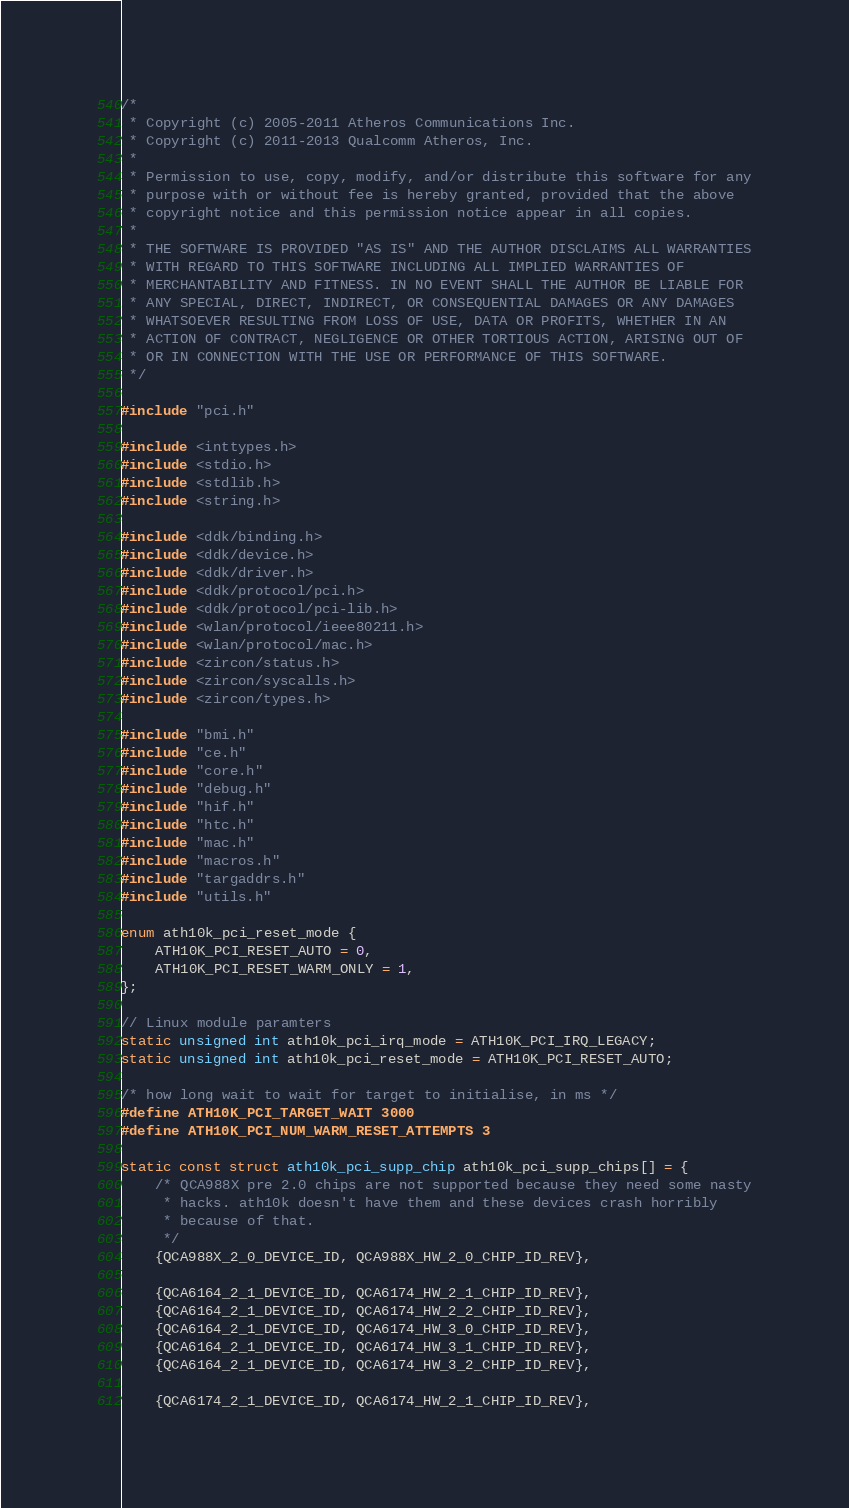Convert code to text. <code><loc_0><loc_0><loc_500><loc_500><_C_>/*
 * Copyright (c) 2005-2011 Atheros Communications Inc.
 * Copyright (c) 2011-2013 Qualcomm Atheros, Inc.
 *
 * Permission to use, copy, modify, and/or distribute this software for any
 * purpose with or without fee is hereby granted, provided that the above
 * copyright notice and this permission notice appear in all copies.
 *
 * THE SOFTWARE IS PROVIDED "AS IS" AND THE AUTHOR DISCLAIMS ALL WARRANTIES
 * WITH REGARD TO THIS SOFTWARE INCLUDING ALL IMPLIED WARRANTIES OF
 * MERCHANTABILITY AND FITNESS. IN NO EVENT SHALL THE AUTHOR BE LIABLE FOR
 * ANY SPECIAL, DIRECT, INDIRECT, OR CONSEQUENTIAL DAMAGES OR ANY DAMAGES
 * WHATSOEVER RESULTING FROM LOSS OF USE, DATA OR PROFITS, WHETHER IN AN
 * ACTION OF CONTRACT, NEGLIGENCE OR OTHER TORTIOUS ACTION, ARISING OUT OF
 * OR IN CONNECTION WITH THE USE OR PERFORMANCE OF THIS SOFTWARE.
 */

#include "pci.h"

#include <inttypes.h>
#include <stdio.h>
#include <stdlib.h>
#include <string.h>

#include <ddk/binding.h>
#include <ddk/device.h>
#include <ddk/driver.h>
#include <ddk/protocol/pci.h>
#include <ddk/protocol/pci-lib.h>
#include <wlan/protocol/ieee80211.h>
#include <wlan/protocol/mac.h>
#include <zircon/status.h>
#include <zircon/syscalls.h>
#include <zircon/types.h>

#include "bmi.h"
#include "ce.h"
#include "core.h"
#include "debug.h"
#include "hif.h"
#include "htc.h"
#include "mac.h"
#include "macros.h"
#include "targaddrs.h"
#include "utils.h"

enum ath10k_pci_reset_mode {
    ATH10K_PCI_RESET_AUTO = 0,
    ATH10K_PCI_RESET_WARM_ONLY = 1,
};

// Linux module paramters
static unsigned int ath10k_pci_irq_mode = ATH10K_PCI_IRQ_LEGACY;
static unsigned int ath10k_pci_reset_mode = ATH10K_PCI_RESET_AUTO;

/* how long wait to wait for target to initialise, in ms */
#define ATH10K_PCI_TARGET_WAIT 3000
#define ATH10K_PCI_NUM_WARM_RESET_ATTEMPTS 3

static const struct ath10k_pci_supp_chip ath10k_pci_supp_chips[] = {
    /* QCA988X pre 2.0 chips are not supported because they need some nasty
     * hacks. ath10k doesn't have them and these devices crash horribly
     * because of that.
     */
    {QCA988X_2_0_DEVICE_ID, QCA988X_HW_2_0_CHIP_ID_REV},

    {QCA6164_2_1_DEVICE_ID, QCA6174_HW_2_1_CHIP_ID_REV},
    {QCA6164_2_1_DEVICE_ID, QCA6174_HW_2_2_CHIP_ID_REV},
    {QCA6164_2_1_DEVICE_ID, QCA6174_HW_3_0_CHIP_ID_REV},
    {QCA6164_2_1_DEVICE_ID, QCA6174_HW_3_1_CHIP_ID_REV},
    {QCA6164_2_1_DEVICE_ID, QCA6174_HW_3_2_CHIP_ID_REV},

    {QCA6174_2_1_DEVICE_ID, QCA6174_HW_2_1_CHIP_ID_REV},</code> 